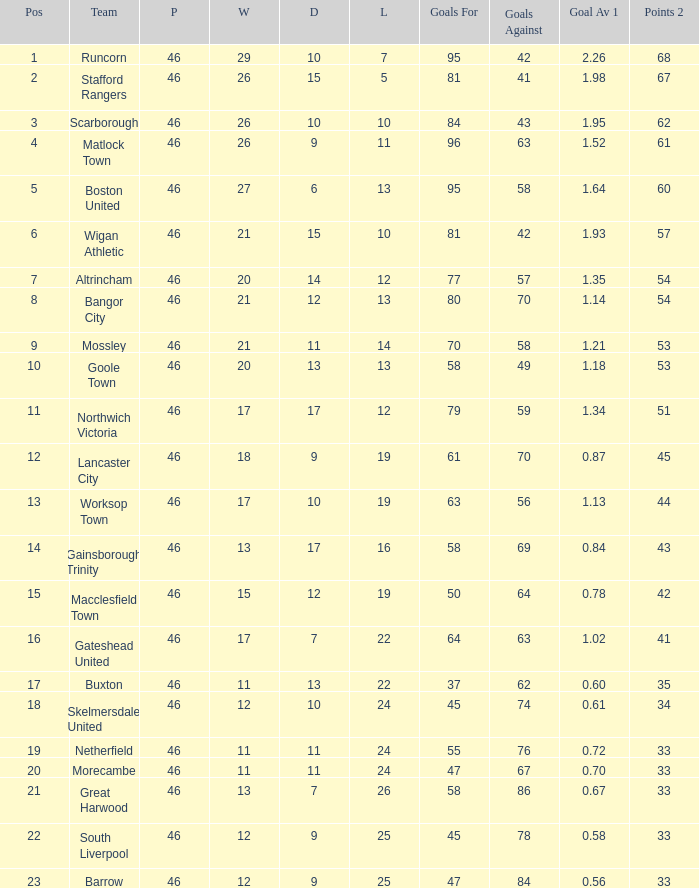What is the peak placement of the bangor city unit? 8.0. 